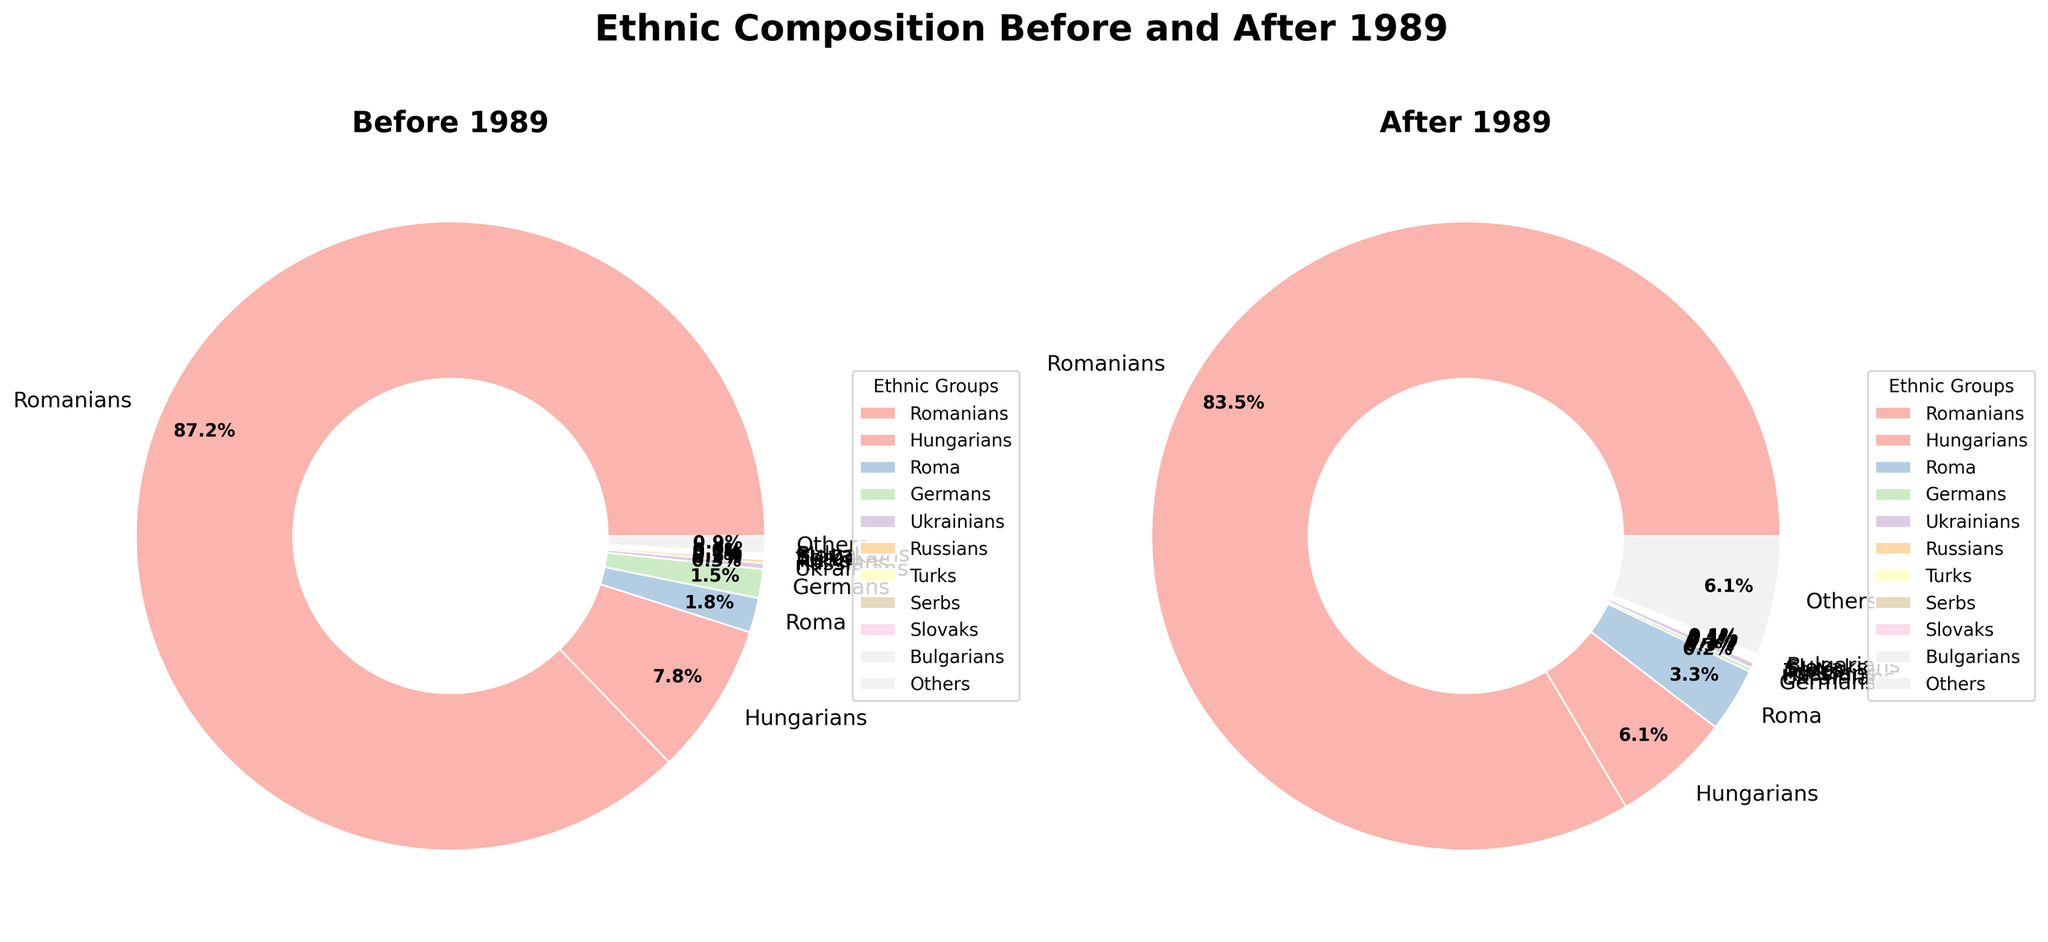What's the percentage difference in the Roma population before and after 1989? The Roma population percentage before 1989 is 1.8%, and after 1989, it is 3.3%. The percentage difference can be calculated as 3.3% - 1.8% = 1.5%.
Answer: 1.5% Which ethnic group had the largest increase in percentage after 1989? By comparing the before and after 1989 percentages, the Roma group increased from 1.8% to 3.3%, an increase of 1.5%.
Answer: Roma Which ethnic group had the largest decrease in percentage after 1989? By comparing the data, the Germans show the largest decrease from 1.5% to 0.2%, which is a decrease of 1.3%.
Answer: Germans What was the combined percentage of 'Others' after 1989? Referring to the pie chart, the percentage of 'Others' after 1989 is 6.1%.
Answer: 6.1% Between Romanians and Hungarians, which ethnic group had a smaller percentage decline after 1989? Romanians declined from 88.1% to 83.5%, a decrease of 4.6%. Hungarians declined from 7.9% to 6.1%, a decrease of 1.8%. Comparing the two, Hungarians had a smaller percentage decline.
Answer: Hungarians What is the ratio of Romanians to the combined percentage of 'Others' after 1989? Romanians had a percentage of 83.5%, and 'Others' had 6.1%. The ratio is 83.5 / 6.1 ≈ 13.7.
Answer: 13.7 Were there any ethnic groups whose percentage remained unchanged before and after 1989? By examining the values, Ukrainians, Turks, Serbs, and Slovaks all remained unchanged at 0.3%, 0.1%, 0.1%, and 0.1% respectively before and after 1989.
Answer: Four groups (Ukrainians, Turks, Serbs, Slovaks) What percentage of the population did Hungarians represent before 1989 compared to Germans? Hungarians represented 7.9% and Germans represented 1.5% before 1989. The difference is 7.9% - 1.5% = 6.4%.
Answer: 6.4% Excluding 'Others,' what was the total percentage change for all ethnic groups combined after 1989? Summing the individual percentage changes for Romanians (-4.6), Hungarians (-1.8), Roma (+1.5), Germans (-1.3), Ukrainians (0), Russians (-0.1), Turks (0), Serbs (0), Slovaks (0), Bulgarians (+0.1), the total is -4.6 - 1.8 +1.5 - 1.3 - 0.1 + 0 + 0 + 0 + 0 + 0.1 = -6.2%.
Answer: -6.2% 